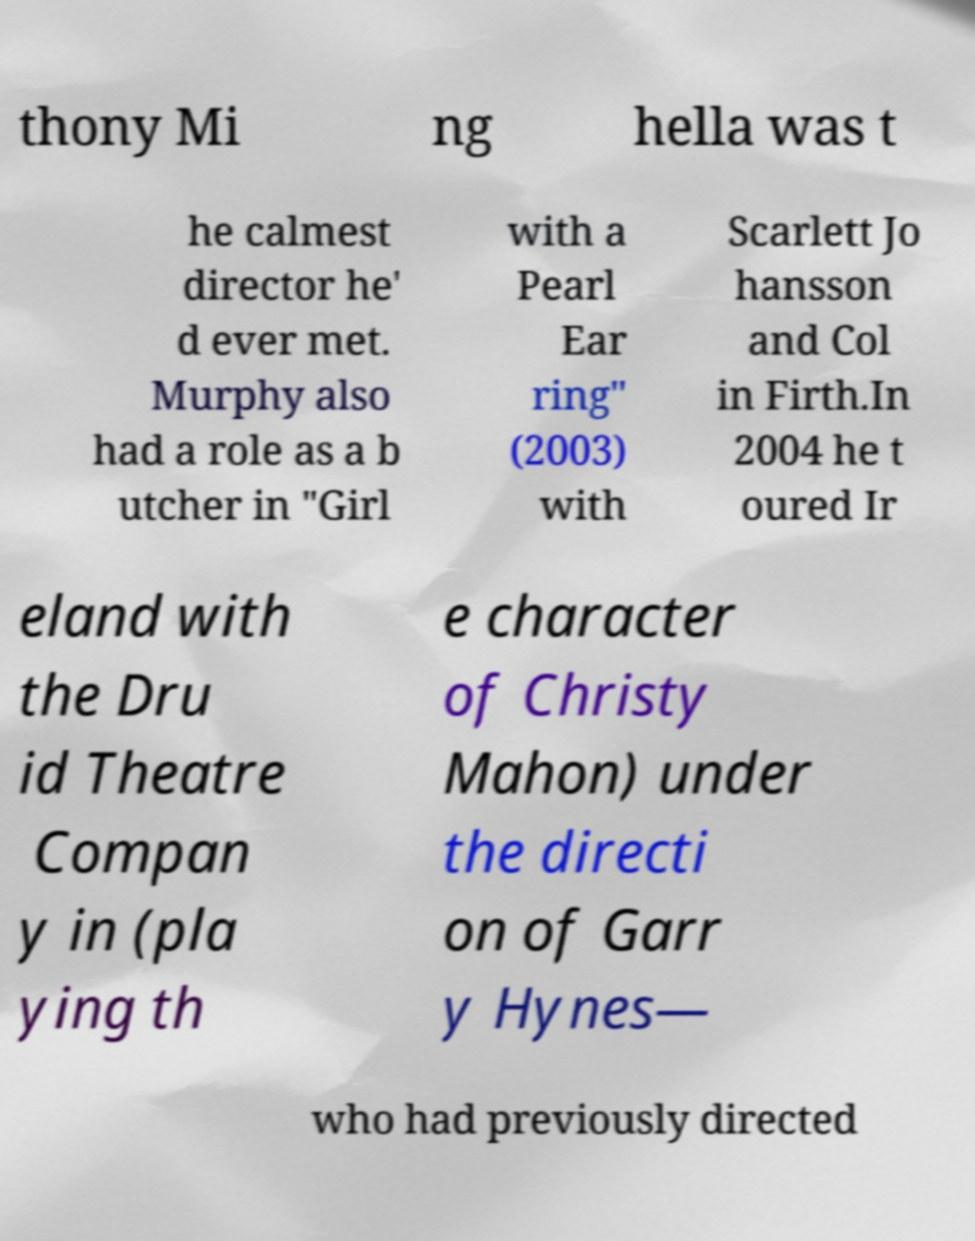Could you assist in decoding the text presented in this image and type it out clearly? thony Mi ng hella was t he calmest director he' d ever met. Murphy also had a role as a b utcher in "Girl with a Pearl Ear ring" (2003) with Scarlett Jo hansson and Col in Firth.In 2004 he t oured Ir eland with the Dru id Theatre Compan y in (pla ying th e character of Christy Mahon) under the directi on of Garr y Hynes— who had previously directed 